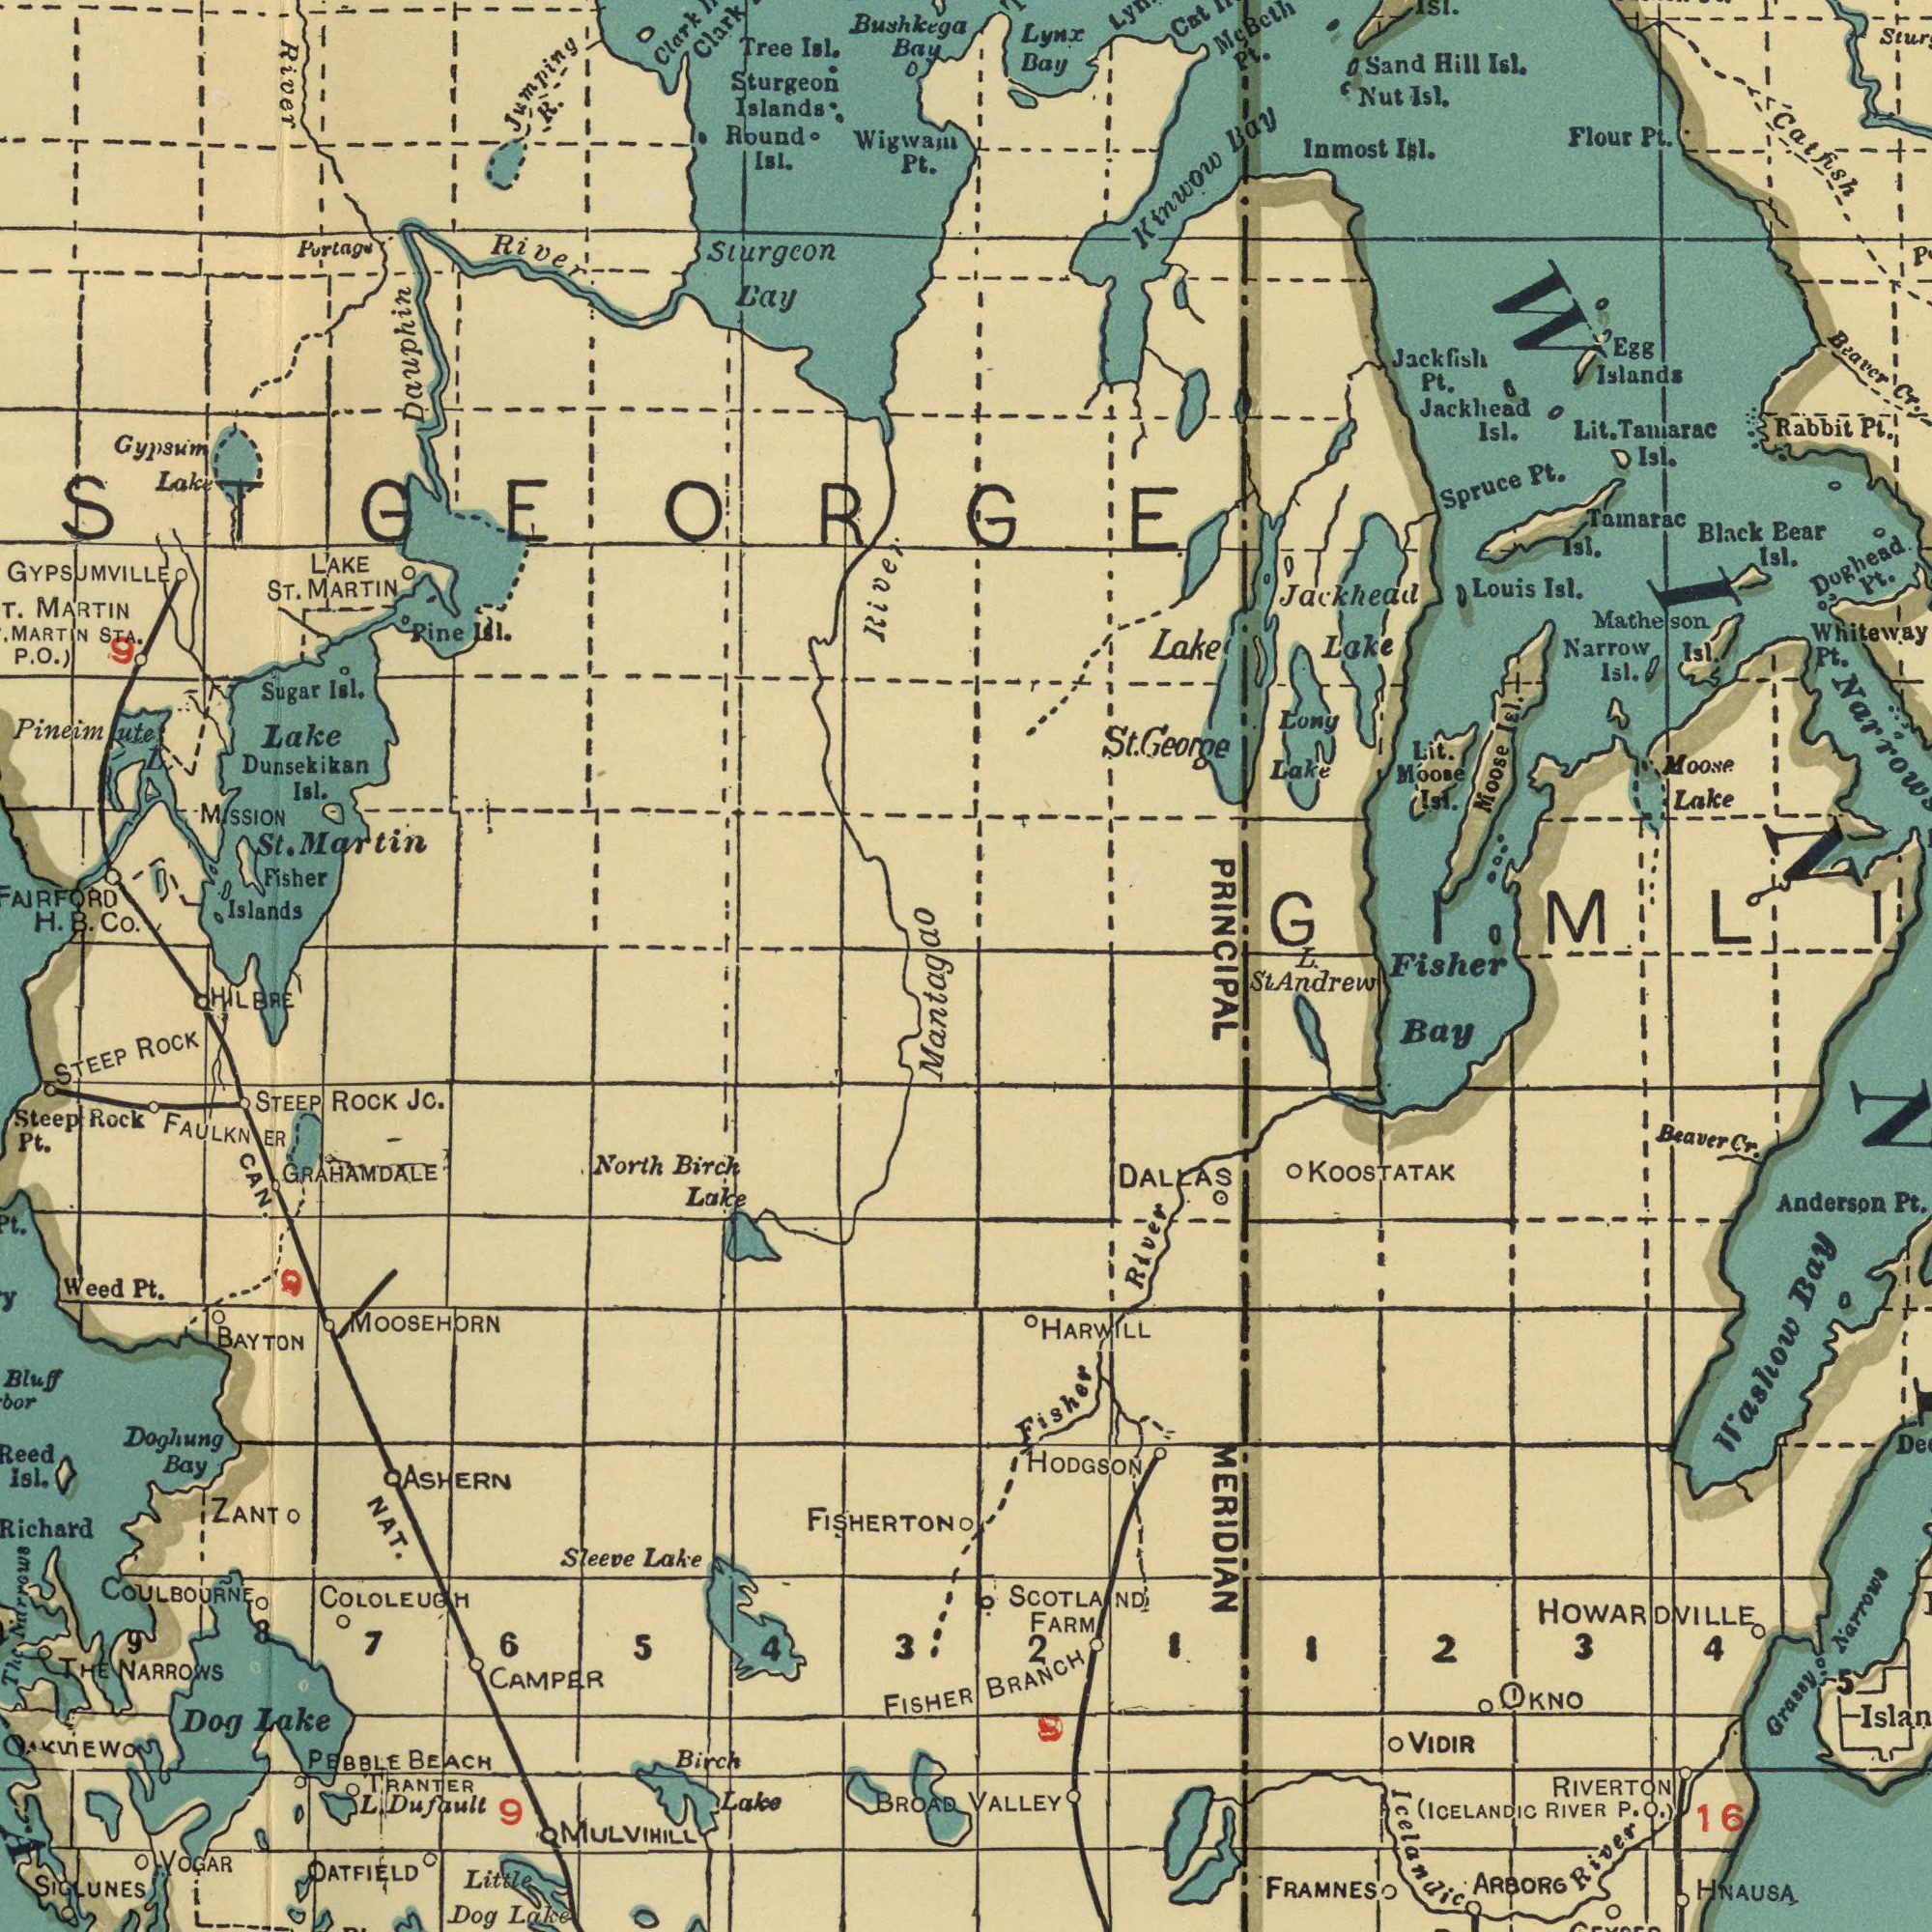What text is shown in the top-right quadrant? Catfish Whiteway Lake Kinwow Islands Bearer Lake Jackhead Doghead Tainarac Inmost Louis Bear Isl. Bay Rabbit Lake Sand Egg Spruce Long Narrow Jackhead Jackfish Pt. Isl. Lynx Moose Pt. Isl. Isl. Moose Bay Mc Nut Isl. Taniarac Pt. Cat lsl. Isl. Hill PRINCIPAL Isl. Moose Isl. Pt. Isl. Lit. Black Pt. Lit. Lake Isl. Pt. Isl. Flour Pt. Matheson Cr. George St. ISI. Beth Fisher L. What text appears in the bottom-left area of the image? MOOSEHORN FISHERTON Little COLOLEUGH SIGLUNES ROCK CAMPER BROAD GRAHAMDALE OATFIELD NAT. NARROWS Richard STEEP L. Lake TRANTER Lake JO. Doghung Birch PEBBLE FISHER Lake Lake Narrows Mantagao Dog Birch HILBRE OAKVIEWO Sleeve STEEP North Bay Isl. Weed CAN. Pt. BEACH Dog ASHERN Pt. ZANT COULBOURNE VOGAR BAYTON 6 5 Bluff Reed The Rock 7 ROCK FAULKNER Dufault 4 Steep 3 9 THE MULVIHILL 9 Lake 8 9 What text can you see in the top-left section? Dauphin Islands Fisher Dunsekikan MARTIN MARTIN Clark Sturgeon Pineimute Bay River Clark River Lake Tree Wigwam Bushkega Co. River MARTIN MISSION Martin Sugar Portage STA. LAKE Islands Sturgeon Isl. Bay Isl. Pt. St. ST. Pine Isl. Isl. Isl. R. P. Jumping H. Lake GYPSUMVILLE Gypsum Round B. ST 9 O.) GEORGE What text appears in the bottom-right area of the image? HODGSON Fisher MERIDIAN St Bay HNAUSA KOOSTATAK Anderson (ICELANDIC RIVERTON HARWILL FRAMNES OKNO VALLEY BRANCH River Beaver River FARM Washow DALLAS RIVER VIDIR 3 4 Bay Narrows 2 ARBORG Cr. 16 2 Pt. P. SCOTLAND 5 HOWARDVILLE 9 Icelandic Grassy Andrew 1 1 O.) 